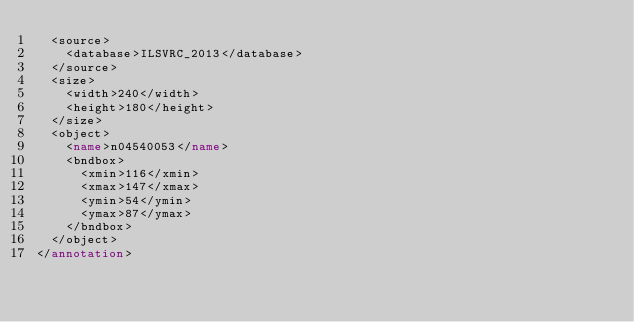<code> <loc_0><loc_0><loc_500><loc_500><_XML_>	<source>
		<database>ILSVRC_2013</database>
	</source>
	<size>
		<width>240</width>
		<height>180</height>
	</size>
	<object>
		<name>n04540053</name>
		<bndbox>
			<xmin>116</xmin>
			<xmax>147</xmax>
			<ymin>54</ymin>
			<ymax>87</ymax>
		</bndbox>
	</object>
</annotation>
</code> 